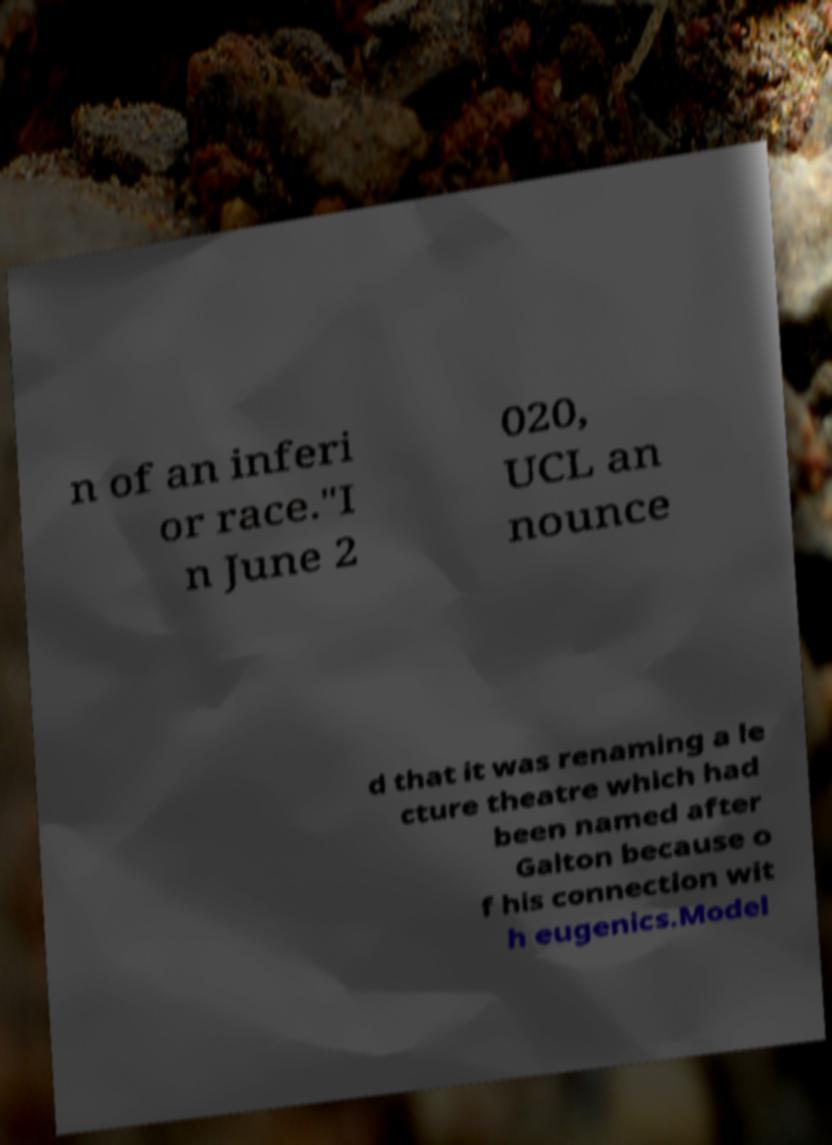What messages or text are displayed in this image? I need them in a readable, typed format. n of an inferi or race."I n June 2 020, UCL an nounce d that it was renaming a le cture theatre which had been named after Galton because o f his connection wit h eugenics.Model 